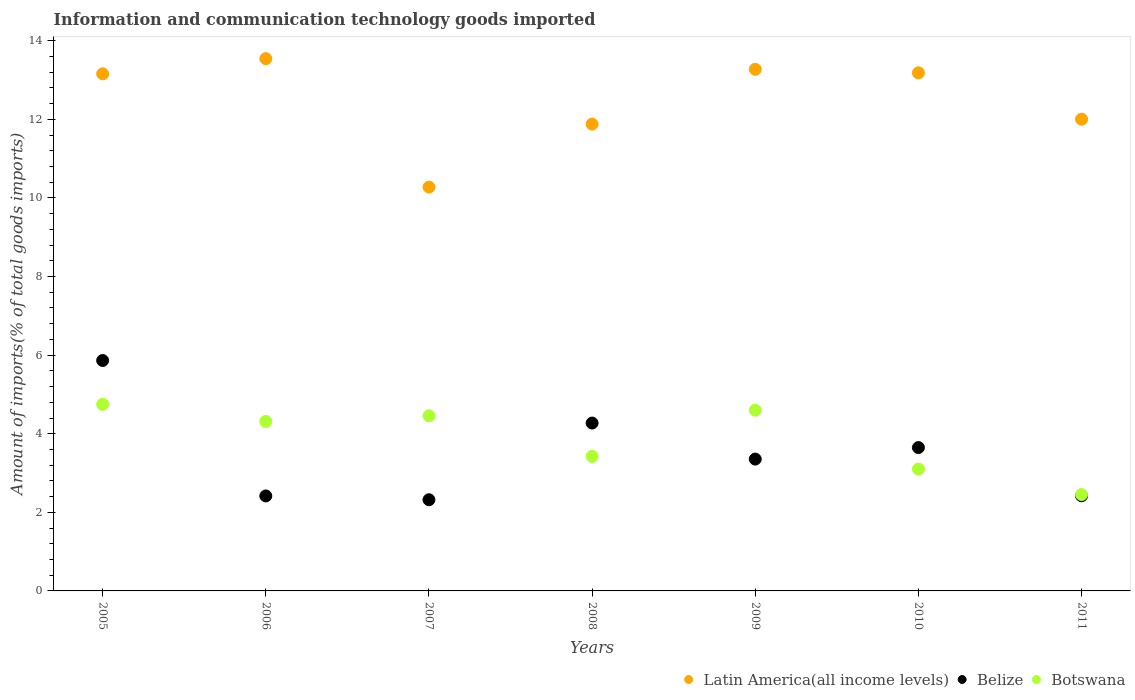How many different coloured dotlines are there?
Your response must be concise. 3. What is the amount of goods imported in Belize in 2007?
Your response must be concise. 2.32. Across all years, what is the maximum amount of goods imported in Belize?
Provide a short and direct response. 5.86. Across all years, what is the minimum amount of goods imported in Belize?
Offer a very short reply. 2.32. What is the total amount of goods imported in Botswana in the graph?
Provide a short and direct response. 27.09. What is the difference between the amount of goods imported in Latin America(all income levels) in 2007 and that in 2008?
Make the answer very short. -1.6. What is the difference between the amount of goods imported in Latin America(all income levels) in 2006 and the amount of goods imported in Botswana in 2005?
Make the answer very short. 8.8. What is the average amount of goods imported in Latin America(all income levels) per year?
Your answer should be compact. 12.47. In the year 2010, what is the difference between the amount of goods imported in Botswana and amount of goods imported in Latin America(all income levels)?
Provide a short and direct response. -10.08. What is the ratio of the amount of goods imported in Belize in 2006 to that in 2008?
Keep it short and to the point. 0.57. Is the amount of goods imported in Belize in 2009 less than that in 2010?
Ensure brevity in your answer.  Yes. Is the difference between the amount of goods imported in Botswana in 2006 and 2007 greater than the difference between the amount of goods imported in Latin America(all income levels) in 2006 and 2007?
Your response must be concise. No. What is the difference between the highest and the second highest amount of goods imported in Botswana?
Offer a terse response. 0.15. What is the difference between the highest and the lowest amount of goods imported in Latin America(all income levels)?
Your answer should be compact. 3.27. In how many years, is the amount of goods imported in Latin America(all income levels) greater than the average amount of goods imported in Latin America(all income levels) taken over all years?
Provide a short and direct response. 4. Is the sum of the amount of goods imported in Latin America(all income levels) in 2006 and 2008 greater than the maximum amount of goods imported in Belize across all years?
Give a very brief answer. Yes. Is it the case that in every year, the sum of the amount of goods imported in Belize and amount of goods imported in Botswana  is greater than the amount of goods imported in Latin America(all income levels)?
Your answer should be very brief. No. Does the amount of goods imported in Belize monotonically increase over the years?
Your answer should be compact. No. Is the amount of goods imported in Botswana strictly less than the amount of goods imported in Latin America(all income levels) over the years?
Your answer should be compact. Yes. How many dotlines are there?
Provide a short and direct response. 3. Are the values on the major ticks of Y-axis written in scientific E-notation?
Make the answer very short. No. Does the graph contain any zero values?
Offer a very short reply. No. Does the graph contain grids?
Provide a short and direct response. No. What is the title of the graph?
Make the answer very short. Information and communication technology goods imported. Does "Finland" appear as one of the legend labels in the graph?
Your answer should be very brief. No. What is the label or title of the X-axis?
Provide a succinct answer. Years. What is the label or title of the Y-axis?
Your answer should be very brief. Amount of imports(% of total goods imports). What is the Amount of imports(% of total goods imports) of Latin America(all income levels) in 2005?
Ensure brevity in your answer.  13.16. What is the Amount of imports(% of total goods imports) of Belize in 2005?
Ensure brevity in your answer.  5.86. What is the Amount of imports(% of total goods imports) of Botswana in 2005?
Your response must be concise. 4.75. What is the Amount of imports(% of total goods imports) in Latin America(all income levels) in 2006?
Offer a very short reply. 13.54. What is the Amount of imports(% of total goods imports) in Belize in 2006?
Make the answer very short. 2.42. What is the Amount of imports(% of total goods imports) in Botswana in 2006?
Your answer should be very brief. 4.31. What is the Amount of imports(% of total goods imports) of Latin America(all income levels) in 2007?
Your response must be concise. 10.28. What is the Amount of imports(% of total goods imports) in Belize in 2007?
Your answer should be compact. 2.32. What is the Amount of imports(% of total goods imports) of Botswana in 2007?
Provide a succinct answer. 4.46. What is the Amount of imports(% of total goods imports) of Latin America(all income levels) in 2008?
Your answer should be very brief. 11.88. What is the Amount of imports(% of total goods imports) of Belize in 2008?
Offer a terse response. 4.27. What is the Amount of imports(% of total goods imports) in Botswana in 2008?
Your answer should be very brief. 3.42. What is the Amount of imports(% of total goods imports) in Latin America(all income levels) in 2009?
Ensure brevity in your answer.  13.27. What is the Amount of imports(% of total goods imports) of Belize in 2009?
Make the answer very short. 3.35. What is the Amount of imports(% of total goods imports) of Botswana in 2009?
Offer a very short reply. 4.6. What is the Amount of imports(% of total goods imports) in Latin America(all income levels) in 2010?
Give a very brief answer. 13.18. What is the Amount of imports(% of total goods imports) in Belize in 2010?
Provide a short and direct response. 3.65. What is the Amount of imports(% of total goods imports) of Botswana in 2010?
Give a very brief answer. 3.1. What is the Amount of imports(% of total goods imports) of Latin America(all income levels) in 2011?
Offer a very short reply. 12.01. What is the Amount of imports(% of total goods imports) of Belize in 2011?
Keep it short and to the point. 2.42. What is the Amount of imports(% of total goods imports) in Botswana in 2011?
Your response must be concise. 2.45. Across all years, what is the maximum Amount of imports(% of total goods imports) of Latin America(all income levels)?
Your answer should be very brief. 13.54. Across all years, what is the maximum Amount of imports(% of total goods imports) in Belize?
Provide a succinct answer. 5.86. Across all years, what is the maximum Amount of imports(% of total goods imports) of Botswana?
Provide a short and direct response. 4.75. Across all years, what is the minimum Amount of imports(% of total goods imports) in Latin America(all income levels)?
Provide a succinct answer. 10.28. Across all years, what is the minimum Amount of imports(% of total goods imports) in Belize?
Your answer should be compact. 2.32. Across all years, what is the minimum Amount of imports(% of total goods imports) in Botswana?
Your answer should be compact. 2.45. What is the total Amount of imports(% of total goods imports) of Latin America(all income levels) in the graph?
Offer a terse response. 87.32. What is the total Amount of imports(% of total goods imports) of Belize in the graph?
Ensure brevity in your answer.  24.3. What is the total Amount of imports(% of total goods imports) in Botswana in the graph?
Provide a succinct answer. 27.09. What is the difference between the Amount of imports(% of total goods imports) of Latin America(all income levels) in 2005 and that in 2006?
Provide a short and direct response. -0.39. What is the difference between the Amount of imports(% of total goods imports) of Belize in 2005 and that in 2006?
Offer a very short reply. 3.45. What is the difference between the Amount of imports(% of total goods imports) of Botswana in 2005 and that in 2006?
Give a very brief answer. 0.43. What is the difference between the Amount of imports(% of total goods imports) in Latin America(all income levels) in 2005 and that in 2007?
Provide a succinct answer. 2.88. What is the difference between the Amount of imports(% of total goods imports) in Belize in 2005 and that in 2007?
Offer a very short reply. 3.54. What is the difference between the Amount of imports(% of total goods imports) in Botswana in 2005 and that in 2007?
Give a very brief answer. 0.29. What is the difference between the Amount of imports(% of total goods imports) in Latin America(all income levels) in 2005 and that in 2008?
Offer a very short reply. 1.28. What is the difference between the Amount of imports(% of total goods imports) in Belize in 2005 and that in 2008?
Ensure brevity in your answer.  1.59. What is the difference between the Amount of imports(% of total goods imports) of Botswana in 2005 and that in 2008?
Ensure brevity in your answer.  1.33. What is the difference between the Amount of imports(% of total goods imports) of Latin America(all income levels) in 2005 and that in 2009?
Provide a short and direct response. -0.12. What is the difference between the Amount of imports(% of total goods imports) of Belize in 2005 and that in 2009?
Offer a very short reply. 2.51. What is the difference between the Amount of imports(% of total goods imports) in Botswana in 2005 and that in 2009?
Offer a very short reply. 0.15. What is the difference between the Amount of imports(% of total goods imports) in Latin America(all income levels) in 2005 and that in 2010?
Your answer should be compact. -0.03. What is the difference between the Amount of imports(% of total goods imports) in Belize in 2005 and that in 2010?
Provide a succinct answer. 2.22. What is the difference between the Amount of imports(% of total goods imports) of Botswana in 2005 and that in 2010?
Your response must be concise. 1.65. What is the difference between the Amount of imports(% of total goods imports) of Latin America(all income levels) in 2005 and that in 2011?
Offer a terse response. 1.15. What is the difference between the Amount of imports(% of total goods imports) in Belize in 2005 and that in 2011?
Keep it short and to the point. 3.44. What is the difference between the Amount of imports(% of total goods imports) of Botswana in 2005 and that in 2011?
Make the answer very short. 2.3. What is the difference between the Amount of imports(% of total goods imports) of Latin America(all income levels) in 2006 and that in 2007?
Provide a short and direct response. 3.27. What is the difference between the Amount of imports(% of total goods imports) in Belize in 2006 and that in 2007?
Offer a very short reply. 0.1. What is the difference between the Amount of imports(% of total goods imports) in Botswana in 2006 and that in 2007?
Make the answer very short. -0.14. What is the difference between the Amount of imports(% of total goods imports) of Latin America(all income levels) in 2006 and that in 2008?
Your answer should be very brief. 1.67. What is the difference between the Amount of imports(% of total goods imports) of Belize in 2006 and that in 2008?
Offer a terse response. -1.85. What is the difference between the Amount of imports(% of total goods imports) in Botswana in 2006 and that in 2008?
Provide a succinct answer. 0.89. What is the difference between the Amount of imports(% of total goods imports) in Latin America(all income levels) in 2006 and that in 2009?
Offer a very short reply. 0.27. What is the difference between the Amount of imports(% of total goods imports) in Belize in 2006 and that in 2009?
Your answer should be very brief. -0.94. What is the difference between the Amount of imports(% of total goods imports) in Botswana in 2006 and that in 2009?
Provide a short and direct response. -0.28. What is the difference between the Amount of imports(% of total goods imports) of Latin America(all income levels) in 2006 and that in 2010?
Your answer should be compact. 0.36. What is the difference between the Amount of imports(% of total goods imports) in Belize in 2006 and that in 2010?
Ensure brevity in your answer.  -1.23. What is the difference between the Amount of imports(% of total goods imports) of Botswana in 2006 and that in 2010?
Offer a very short reply. 1.21. What is the difference between the Amount of imports(% of total goods imports) in Latin America(all income levels) in 2006 and that in 2011?
Give a very brief answer. 1.54. What is the difference between the Amount of imports(% of total goods imports) in Belize in 2006 and that in 2011?
Make the answer very short. -0. What is the difference between the Amount of imports(% of total goods imports) in Botswana in 2006 and that in 2011?
Provide a short and direct response. 1.86. What is the difference between the Amount of imports(% of total goods imports) in Latin America(all income levels) in 2007 and that in 2008?
Your answer should be compact. -1.6. What is the difference between the Amount of imports(% of total goods imports) of Belize in 2007 and that in 2008?
Your answer should be very brief. -1.95. What is the difference between the Amount of imports(% of total goods imports) of Botswana in 2007 and that in 2008?
Your answer should be compact. 1.03. What is the difference between the Amount of imports(% of total goods imports) of Latin America(all income levels) in 2007 and that in 2009?
Ensure brevity in your answer.  -3. What is the difference between the Amount of imports(% of total goods imports) of Belize in 2007 and that in 2009?
Keep it short and to the point. -1.03. What is the difference between the Amount of imports(% of total goods imports) of Botswana in 2007 and that in 2009?
Offer a very short reply. -0.14. What is the difference between the Amount of imports(% of total goods imports) in Latin America(all income levels) in 2007 and that in 2010?
Offer a very short reply. -2.91. What is the difference between the Amount of imports(% of total goods imports) of Belize in 2007 and that in 2010?
Offer a very short reply. -1.33. What is the difference between the Amount of imports(% of total goods imports) of Botswana in 2007 and that in 2010?
Give a very brief answer. 1.36. What is the difference between the Amount of imports(% of total goods imports) of Latin America(all income levels) in 2007 and that in 2011?
Keep it short and to the point. -1.73. What is the difference between the Amount of imports(% of total goods imports) in Belize in 2007 and that in 2011?
Provide a succinct answer. -0.1. What is the difference between the Amount of imports(% of total goods imports) in Botswana in 2007 and that in 2011?
Your answer should be very brief. 2. What is the difference between the Amount of imports(% of total goods imports) of Latin America(all income levels) in 2008 and that in 2009?
Your answer should be compact. -1.4. What is the difference between the Amount of imports(% of total goods imports) in Belize in 2008 and that in 2009?
Provide a short and direct response. 0.92. What is the difference between the Amount of imports(% of total goods imports) in Botswana in 2008 and that in 2009?
Offer a very short reply. -1.18. What is the difference between the Amount of imports(% of total goods imports) of Latin America(all income levels) in 2008 and that in 2010?
Provide a short and direct response. -1.3. What is the difference between the Amount of imports(% of total goods imports) in Belize in 2008 and that in 2010?
Provide a succinct answer. 0.62. What is the difference between the Amount of imports(% of total goods imports) of Botswana in 2008 and that in 2010?
Offer a very short reply. 0.32. What is the difference between the Amount of imports(% of total goods imports) of Latin America(all income levels) in 2008 and that in 2011?
Keep it short and to the point. -0.13. What is the difference between the Amount of imports(% of total goods imports) of Belize in 2008 and that in 2011?
Provide a short and direct response. 1.85. What is the difference between the Amount of imports(% of total goods imports) of Botswana in 2008 and that in 2011?
Provide a succinct answer. 0.97. What is the difference between the Amount of imports(% of total goods imports) of Latin America(all income levels) in 2009 and that in 2010?
Your answer should be compact. 0.09. What is the difference between the Amount of imports(% of total goods imports) of Belize in 2009 and that in 2010?
Your answer should be compact. -0.29. What is the difference between the Amount of imports(% of total goods imports) of Botswana in 2009 and that in 2010?
Provide a succinct answer. 1.5. What is the difference between the Amount of imports(% of total goods imports) in Latin America(all income levels) in 2009 and that in 2011?
Your answer should be very brief. 1.27. What is the difference between the Amount of imports(% of total goods imports) in Belize in 2009 and that in 2011?
Ensure brevity in your answer.  0.93. What is the difference between the Amount of imports(% of total goods imports) in Botswana in 2009 and that in 2011?
Ensure brevity in your answer.  2.15. What is the difference between the Amount of imports(% of total goods imports) in Latin America(all income levels) in 2010 and that in 2011?
Provide a short and direct response. 1.18. What is the difference between the Amount of imports(% of total goods imports) of Belize in 2010 and that in 2011?
Offer a terse response. 1.23. What is the difference between the Amount of imports(% of total goods imports) of Botswana in 2010 and that in 2011?
Ensure brevity in your answer.  0.65. What is the difference between the Amount of imports(% of total goods imports) of Latin America(all income levels) in 2005 and the Amount of imports(% of total goods imports) of Belize in 2006?
Ensure brevity in your answer.  10.74. What is the difference between the Amount of imports(% of total goods imports) in Latin America(all income levels) in 2005 and the Amount of imports(% of total goods imports) in Botswana in 2006?
Offer a very short reply. 8.84. What is the difference between the Amount of imports(% of total goods imports) in Belize in 2005 and the Amount of imports(% of total goods imports) in Botswana in 2006?
Your answer should be very brief. 1.55. What is the difference between the Amount of imports(% of total goods imports) in Latin America(all income levels) in 2005 and the Amount of imports(% of total goods imports) in Belize in 2007?
Offer a very short reply. 10.84. What is the difference between the Amount of imports(% of total goods imports) of Latin America(all income levels) in 2005 and the Amount of imports(% of total goods imports) of Botswana in 2007?
Give a very brief answer. 8.7. What is the difference between the Amount of imports(% of total goods imports) in Belize in 2005 and the Amount of imports(% of total goods imports) in Botswana in 2007?
Your response must be concise. 1.41. What is the difference between the Amount of imports(% of total goods imports) in Latin America(all income levels) in 2005 and the Amount of imports(% of total goods imports) in Belize in 2008?
Your answer should be compact. 8.89. What is the difference between the Amount of imports(% of total goods imports) in Latin America(all income levels) in 2005 and the Amount of imports(% of total goods imports) in Botswana in 2008?
Offer a terse response. 9.74. What is the difference between the Amount of imports(% of total goods imports) in Belize in 2005 and the Amount of imports(% of total goods imports) in Botswana in 2008?
Your answer should be very brief. 2.44. What is the difference between the Amount of imports(% of total goods imports) of Latin America(all income levels) in 2005 and the Amount of imports(% of total goods imports) of Belize in 2009?
Offer a terse response. 9.8. What is the difference between the Amount of imports(% of total goods imports) of Latin America(all income levels) in 2005 and the Amount of imports(% of total goods imports) of Botswana in 2009?
Ensure brevity in your answer.  8.56. What is the difference between the Amount of imports(% of total goods imports) of Belize in 2005 and the Amount of imports(% of total goods imports) of Botswana in 2009?
Keep it short and to the point. 1.26. What is the difference between the Amount of imports(% of total goods imports) of Latin America(all income levels) in 2005 and the Amount of imports(% of total goods imports) of Belize in 2010?
Your response must be concise. 9.51. What is the difference between the Amount of imports(% of total goods imports) of Latin America(all income levels) in 2005 and the Amount of imports(% of total goods imports) of Botswana in 2010?
Ensure brevity in your answer.  10.06. What is the difference between the Amount of imports(% of total goods imports) in Belize in 2005 and the Amount of imports(% of total goods imports) in Botswana in 2010?
Your answer should be very brief. 2.76. What is the difference between the Amount of imports(% of total goods imports) in Latin America(all income levels) in 2005 and the Amount of imports(% of total goods imports) in Belize in 2011?
Keep it short and to the point. 10.74. What is the difference between the Amount of imports(% of total goods imports) in Latin America(all income levels) in 2005 and the Amount of imports(% of total goods imports) in Botswana in 2011?
Ensure brevity in your answer.  10.71. What is the difference between the Amount of imports(% of total goods imports) of Belize in 2005 and the Amount of imports(% of total goods imports) of Botswana in 2011?
Provide a short and direct response. 3.41. What is the difference between the Amount of imports(% of total goods imports) of Latin America(all income levels) in 2006 and the Amount of imports(% of total goods imports) of Belize in 2007?
Offer a very short reply. 11.22. What is the difference between the Amount of imports(% of total goods imports) in Latin America(all income levels) in 2006 and the Amount of imports(% of total goods imports) in Botswana in 2007?
Offer a very short reply. 9.09. What is the difference between the Amount of imports(% of total goods imports) of Belize in 2006 and the Amount of imports(% of total goods imports) of Botswana in 2007?
Ensure brevity in your answer.  -2.04. What is the difference between the Amount of imports(% of total goods imports) of Latin America(all income levels) in 2006 and the Amount of imports(% of total goods imports) of Belize in 2008?
Your answer should be very brief. 9.27. What is the difference between the Amount of imports(% of total goods imports) of Latin America(all income levels) in 2006 and the Amount of imports(% of total goods imports) of Botswana in 2008?
Offer a very short reply. 10.12. What is the difference between the Amount of imports(% of total goods imports) of Belize in 2006 and the Amount of imports(% of total goods imports) of Botswana in 2008?
Provide a short and direct response. -1.01. What is the difference between the Amount of imports(% of total goods imports) of Latin America(all income levels) in 2006 and the Amount of imports(% of total goods imports) of Belize in 2009?
Give a very brief answer. 10.19. What is the difference between the Amount of imports(% of total goods imports) in Latin America(all income levels) in 2006 and the Amount of imports(% of total goods imports) in Botswana in 2009?
Make the answer very short. 8.95. What is the difference between the Amount of imports(% of total goods imports) of Belize in 2006 and the Amount of imports(% of total goods imports) of Botswana in 2009?
Provide a succinct answer. -2.18. What is the difference between the Amount of imports(% of total goods imports) of Latin America(all income levels) in 2006 and the Amount of imports(% of total goods imports) of Belize in 2010?
Ensure brevity in your answer.  9.9. What is the difference between the Amount of imports(% of total goods imports) in Latin America(all income levels) in 2006 and the Amount of imports(% of total goods imports) in Botswana in 2010?
Keep it short and to the point. 10.44. What is the difference between the Amount of imports(% of total goods imports) of Belize in 2006 and the Amount of imports(% of total goods imports) of Botswana in 2010?
Your response must be concise. -0.68. What is the difference between the Amount of imports(% of total goods imports) in Latin America(all income levels) in 2006 and the Amount of imports(% of total goods imports) in Belize in 2011?
Your answer should be compact. 11.12. What is the difference between the Amount of imports(% of total goods imports) of Latin America(all income levels) in 2006 and the Amount of imports(% of total goods imports) of Botswana in 2011?
Make the answer very short. 11.09. What is the difference between the Amount of imports(% of total goods imports) in Belize in 2006 and the Amount of imports(% of total goods imports) in Botswana in 2011?
Offer a terse response. -0.04. What is the difference between the Amount of imports(% of total goods imports) of Latin America(all income levels) in 2007 and the Amount of imports(% of total goods imports) of Belize in 2008?
Your answer should be very brief. 6. What is the difference between the Amount of imports(% of total goods imports) in Latin America(all income levels) in 2007 and the Amount of imports(% of total goods imports) in Botswana in 2008?
Give a very brief answer. 6.85. What is the difference between the Amount of imports(% of total goods imports) of Belize in 2007 and the Amount of imports(% of total goods imports) of Botswana in 2008?
Your response must be concise. -1.1. What is the difference between the Amount of imports(% of total goods imports) in Latin America(all income levels) in 2007 and the Amount of imports(% of total goods imports) in Belize in 2009?
Make the answer very short. 6.92. What is the difference between the Amount of imports(% of total goods imports) of Latin America(all income levels) in 2007 and the Amount of imports(% of total goods imports) of Botswana in 2009?
Offer a terse response. 5.68. What is the difference between the Amount of imports(% of total goods imports) in Belize in 2007 and the Amount of imports(% of total goods imports) in Botswana in 2009?
Ensure brevity in your answer.  -2.28. What is the difference between the Amount of imports(% of total goods imports) in Latin America(all income levels) in 2007 and the Amount of imports(% of total goods imports) in Belize in 2010?
Your response must be concise. 6.63. What is the difference between the Amount of imports(% of total goods imports) of Latin America(all income levels) in 2007 and the Amount of imports(% of total goods imports) of Botswana in 2010?
Your answer should be compact. 7.18. What is the difference between the Amount of imports(% of total goods imports) in Belize in 2007 and the Amount of imports(% of total goods imports) in Botswana in 2010?
Your answer should be very brief. -0.78. What is the difference between the Amount of imports(% of total goods imports) of Latin America(all income levels) in 2007 and the Amount of imports(% of total goods imports) of Belize in 2011?
Your answer should be compact. 7.86. What is the difference between the Amount of imports(% of total goods imports) in Latin America(all income levels) in 2007 and the Amount of imports(% of total goods imports) in Botswana in 2011?
Ensure brevity in your answer.  7.82. What is the difference between the Amount of imports(% of total goods imports) of Belize in 2007 and the Amount of imports(% of total goods imports) of Botswana in 2011?
Ensure brevity in your answer.  -0.13. What is the difference between the Amount of imports(% of total goods imports) in Latin America(all income levels) in 2008 and the Amount of imports(% of total goods imports) in Belize in 2009?
Keep it short and to the point. 8.52. What is the difference between the Amount of imports(% of total goods imports) of Latin America(all income levels) in 2008 and the Amount of imports(% of total goods imports) of Botswana in 2009?
Provide a short and direct response. 7.28. What is the difference between the Amount of imports(% of total goods imports) in Belize in 2008 and the Amount of imports(% of total goods imports) in Botswana in 2009?
Give a very brief answer. -0.33. What is the difference between the Amount of imports(% of total goods imports) in Latin America(all income levels) in 2008 and the Amount of imports(% of total goods imports) in Belize in 2010?
Your answer should be very brief. 8.23. What is the difference between the Amount of imports(% of total goods imports) of Latin America(all income levels) in 2008 and the Amount of imports(% of total goods imports) of Botswana in 2010?
Your response must be concise. 8.78. What is the difference between the Amount of imports(% of total goods imports) in Belize in 2008 and the Amount of imports(% of total goods imports) in Botswana in 2010?
Your response must be concise. 1.17. What is the difference between the Amount of imports(% of total goods imports) in Latin America(all income levels) in 2008 and the Amount of imports(% of total goods imports) in Belize in 2011?
Ensure brevity in your answer.  9.46. What is the difference between the Amount of imports(% of total goods imports) in Latin America(all income levels) in 2008 and the Amount of imports(% of total goods imports) in Botswana in 2011?
Ensure brevity in your answer.  9.43. What is the difference between the Amount of imports(% of total goods imports) of Belize in 2008 and the Amount of imports(% of total goods imports) of Botswana in 2011?
Your answer should be compact. 1.82. What is the difference between the Amount of imports(% of total goods imports) in Latin America(all income levels) in 2009 and the Amount of imports(% of total goods imports) in Belize in 2010?
Give a very brief answer. 9.63. What is the difference between the Amount of imports(% of total goods imports) of Latin America(all income levels) in 2009 and the Amount of imports(% of total goods imports) of Botswana in 2010?
Your answer should be very brief. 10.17. What is the difference between the Amount of imports(% of total goods imports) of Belize in 2009 and the Amount of imports(% of total goods imports) of Botswana in 2010?
Keep it short and to the point. 0.25. What is the difference between the Amount of imports(% of total goods imports) in Latin America(all income levels) in 2009 and the Amount of imports(% of total goods imports) in Belize in 2011?
Provide a short and direct response. 10.85. What is the difference between the Amount of imports(% of total goods imports) in Latin America(all income levels) in 2009 and the Amount of imports(% of total goods imports) in Botswana in 2011?
Make the answer very short. 10.82. What is the difference between the Amount of imports(% of total goods imports) in Belize in 2009 and the Amount of imports(% of total goods imports) in Botswana in 2011?
Offer a very short reply. 0.9. What is the difference between the Amount of imports(% of total goods imports) of Latin America(all income levels) in 2010 and the Amount of imports(% of total goods imports) of Belize in 2011?
Provide a short and direct response. 10.76. What is the difference between the Amount of imports(% of total goods imports) in Latin America(all income levels) in 2010 and the Amount of imports(% of total goods imports) in Botswana in 2011?
Make the answer very short. 10.73. What is the difference between the Amount of imports(% of total goods imports) in Belize in 2010 and the Amount of imports(% of total goods imports) in Botswana in 2011?
Your response must be concise. 1.2. What is the average Amount of imports(% of total goods imports) in Latin America(all income levels) per year?
Ensure brevity in your answer.  12.47. What is the average Amount of imports(% of total goods imports) of Belize per year?
Keep it short and to the point. 3.47. What is the average Amount of imports(% of total goods imports) in Botswana per year?
Make the answer very short. 3.87. In the year 2005, what is the difference between the Amount of imports(% of total goods imports) of Latin America(all income levels) and Amount of imports(% of total goods imports) of Belize?
Provide a succinct answer. 7.29. In the year 2005, what is the difference between the Amount of imports(% of total goods imports) of Latin America(all income levels) and Amount of imports(% of total goods imports) of Botswana?
Ensure brevity in your answer.  8.41. In the year 2005, what is the difference between the Amount of imports(% of total goods imports) of Belize and Amount of imports(% of total goods imports) of Botswana?
Offer a terse response. 1.11. In the year 2006, what is the difference between the Amount of imports(% of total goods imports) in Latin America(all income levels) and Amount of imports(% of total goods imports) in Belize?
Give a very brief answer. 11.13. In the year 2006, what is the difference between the Amount of imports(% of total goods imports) of Latin America(all income levels) and Amount of imports(% of total goods imports) of Botswana?
Give a very brief answer. 9.23. In the year 2006, what is the difference between the Amount of imports(% of total goods imports) of Belize and Amount of imports(% of total goods imports) of Botswana?
Make the answer very short. -1.9. In the year 2007, what is the difference between the Amount of imports(% of total goods imports) of Latin America(all income levels) and Amount of imports(% of total goods imports) of Belize?
Your response must be concise. 7.96. In the year 2007, what is the difference between the Amount of imports(% of total goods imports) of Latin America(all income levels) and Amount of imports(% of total goods imports) of Botswana?
Offer a very short reply. 5.82. In the year 2007, what is the difference between the Amount of imports(% of total goods imports) in Belize and Amount of imports(% of total goods imports) in Botswana?
Your answer should be very brief. -2.14. In the year 2008, what is the difference between the Amount of imports(% of total goods imports) in Latin America(all income levels) and Amount of imports(% of total goods imports) in Belize?
Your answer should be very brief. 7.61. In the year 2008, what is the difference between the Amount of imports(% of total goods imports) of Latin America(all income levels) and Amount of imports(% of total goods imports) of Botswana?
Make the answer very short. 8.46. In the year 2008, what is the difference between the Amount of imports(% of total goods imports) of Belize and Amount of imports(% of total goods imports) of Botswana?
Your answer should be very brief. 0.85. In the year 2009, what is the difference between the Amount of imports(% of total goods imports) of Latin America(all income levels) and Amount of imports(% of total goods imports) of Belize?
Provide a short and direct response. 9.92. In the year 2009, what is the difference between the Amount of imports(% of total goods imports) of Latin America(all income levels) and Amount of imports(% of total goods imports) of Botswana?
Your response must be concise. 8.68. In the year 2009, what is the difference between the Amount of imports(% of total goods imports) in Belize and Amount of imports(% of total goods imports) in Botswana?
Provide a succinct answer. -1.24. In the year 2010, what is the difference between the Amount of imports(% of total goods imports) in Latin America(all income levels) and Amount of imports(% of total goods imports) in Belize?
Provide a succinct answer. 9.54. In the year 2010, what is the difference between the Amount of imports(% of total goods imports) in Latin America(all income levels) and Amount of imports(% of total goods imports) in Botswana?
Provide a succinct answer. 10.08. In the year 2010, what is the difference between the Amount of imports(% of total goods imports) of Belize and Amount of imports(% of total goods imports) of Botswana?
Your answer should be compact. 0.55. In the year 2011, what is the difference between the Amount of imports(% of total goods imports) in Latin America(all income levels) and Amount of imports(% of total goods imports) in Belize?
Your response must be concise. 9.58. In the year 2011, what is the difference between the Amount of imports(% of total goods imports) of Latin America(all income levels) and Amount of imports(% of total goods imports) of Botswana?
Offer a very short reply. 9.55. In the year 2011, what is the difference between the Amount of imports(% of total goods imports) in Belize and Amount of imports(% of total goods imports) in Botswana?
Provide a short and direct response. -0.03. What is the ratio of the Amount of imports(% of total goods imports) in Latin America(all income levels) in 2005 to that in 2006?
Provide a succinct answer. 0.97. What is the ratio of the Amount of imports(% of total goods imports) of Belize in 2005 to that in 2006?
Offer a very short reply. 2.43. What is the ratio of the Amount of imports(% of total goods imports) of Botswana in 2005 to that in 2006?
Ensure brevity in your answer.  1.1. What is the ratio of the Amount of imports(% of total goods imports) in Latin America(all income levels) in 2005 to that in 2007?
Provide a short and direct response. 1.28. What is the ratio of the Amount of imports(% of total goods imports) of Belize in 2005 to that in 2007?
Ensure brevity in your answer.  2.53. What is the ratio of the Amount of imports(% of total goods imports) in Botswana in 2005 to that in 2007?
Ensure brevity in your answer.  1.07. What is the ratio of the Amount of imports(% of total goods imports) in Latin America(all income levels) in 2005 to that in 2008?
Give a very brief answer. 1.11. What is the ratio of the Amount of imports(% of total goods imports) in Belize in 2005 to that in 2008?
Provide a short and direct response. 1.37. What is the ratio of the Amount of imports(% of total goods imports) in Botswana in 2005 to that in 2008?
Make the answer very short. 1.39. What is the ratio of the Amount of imports(% of total goods imports) in Belize in 2005 to that in 2009?
Give a very brief answer. 1.75. What is the ratio of the Amount of imports(% of total goods imports) of Botswana in 2005 to that in 2009?
Offer a terse response. 1.03. What is the ratio of the Amount of imports(% of total goods imports) of Latin America(all income levels) in 2005 to that in 2010?
Make the answer very short. 1. What is the ratio of the Amount of imports(% of total goods imports) of Belize in 2005 to that in 2010?
Your answer should be very brief. 1.61. What is the ratio of the Amount of imports(% of total goods imports) in Botswana in 2005 to that in 2010?
Make the answer very short. 1.53. What is the ratio of the Amount of imports(% of total goods imports) of Latin America(all income levels) in 2005 to that in 2011?
Give a very brief answer. 1.1. What is the ratio of the Amount of imports(% of total goods imports) of Belize in 2005 to that in 2011?
Make the answer very short. 2.42. What is the ratio of the Amount of imports(% of total goods imports) in Botswana in 2005 to that in 2011?
Ensure brevity in your answer.  1.94. What is the ratio of the Amount of imports(% of total goods imports) of Latin America(all income levels) in 2006 to that in 2007?
Offer a very short reply. 1.32. What is the ratio of the Amount of imports(% of total goods imports) of Belize in 2006 to that in 2007?
Provide a succinct answer. 1.04. What is the ratio of the Amount of imports(% of total goods imports) of Botswana in 2006 to that in 2007?
Your answer should be compact. 0.97. What is the ratio of the Amount of imports(% of total goods imports) in Latin America(all income levels) in 2006 to that in 2008?
Offer a very short reply. 1.14. What is the ratio of the Amount of imports(% of total goods imports) of Belize in 2006 to that in 2008?
Give a very brief answer. 0.57. What is the ratio of the Amount of imports(% of total goods imports) of Botswana in 2006 to that in 2008?
Provide a succinct answer. 1.26. What is the ratio of the Amount of imports(% of total goods imports) in Latin America(all income levels) in 2006 to that in 2009?
Provide a succinct answer. 1.02. What is the ratio of the Amount of imports(% of total goods imports) in Belize in 2006 to that in 2009?
Make the answer very short. 0.72. What is the ratio of the Amount of imports(% of total goods imports) in Botswana in 2006 to that in 2009?
Your response must be concise. 0.94. What is the ratio of the Amount of imports(% of total goods imports) in Latin America(all income levels) in 2006 to that in 2010?
Provide a succinct answer. 1.03. What is the ratio of the Amount of imports(% of total goods imports) in Belize in 2006 to that in 2010?
Offer a terse response. 0.66. What is the ratio of the Amount of imports(% of total goods imports) in Botswana in 2006 to that in 2010?
Your answer should be very brief. 1.39. What is the ratio of the Amount of imports(% of total goods imports) in Latin America(all income levels) in 2006 to that in 2011?
Keep it short and to the point. 1.13. What is the ratio of the Amount of imports(% of total goods imports) in Botswana in 2006 to that in 2011?
Ensure brevity in your answer.  1.76. What is the ratio of the Amount of imports(% of total goods imports) in Latin America(all income levels) in 2007 to that in 2008?
Make the answer very short. 0.87. What is the ratio of the Amount of imports(% of total goods imports) of Belize in 2007 to that in 2008?
Provide a short and direct response. 0.54. What is the ratio of the Amount of imports(% of total goods imports) of Botswana in 2007 to that in 2008?
Make the answer very short. 1.3. What is the ratio of the Amount of imports(% of total goods imports) of Latin America(all income levels) in 2007 to that in 2009?
Provide a short and direct response. 0.77. What is the ratio of the Amount of imports(% of total goods imports) in Belize in 2007 to that in 2009?
Your answer should be very brief. 0.69. What is the ratio of the Amount of imports(% of total goods imports) of Botswana in 2007 to that in 2009?
Your answer should be compact. 0.97. What is the ratio of the Amount of imports(% of total goods imports) of Latin America(all income levels) in 2007 to that in 2010?
Give a very brief answer. 0.78. What is the ratio of the Amount of imports(% of total goods imports) of Belize in 2007 to that in 2010?
Your answer should be very brief. 0.64. What is the ratio of the Amount of imports(% of total goods imports) in Botswana in 2007 to that in 2010?
Provide a short and direct response. 1.44. What is the ratio of the Amount of imports(% of total goods imports) of Latin America(all income levels) in 2007 to that in 2011?
Your answer should be very brief. 0.86. What is the ratio of the Amount of imports(% of total goods imports) in Belize in 2007 to that in 2011?
Provide a short and direct response. 0.96. What is the ratio of the Amount of imports(% of total goods imports) of Botswana in 2007 to that in 2011?
Your response must be concise. 1.82. What is the ratio of the Amount of imports(% of total goods imports) of Latin America(all income levels) in 2008 to that in 2009?
Offer a very short reply. 0.89. What is the ratio of the Amount of imports(% of total goods imports) of Belize in 2008 to that in 2009?
Provide a succinct answer. 1.27. What is the ratio of the Amount of imports(% of total goods imports) of Botswana in 2008 to that in 2009?
Provide a succinct answer. 0.74. What is the ratio of the Amount of imports(% of total goods imports) in Latin America(all income levels) in 2008 to that in 2010?
Your answer should be compact. 0.9. What is the ratio of the Amount of imports(% of total goods imports) in Belize in 2008 to that in 2010?
Keep it short and to the point. 1.17. What is the ratio of the Amount of imports(% of total goods imports) in Botswana in 2008 to that in 2010?
Provide a succinct answer. 1.1. What is the ratio of the Amount of imports(% of total goods imports) in Belize in 2008 to that in 2011?
Ensure brevity in your answer.  1.76. What is the ratio of the Amount of imports(% of total goods imports) in Botswana in 2008 to that in 2011?
Offer a very short reply. 1.4. What is the ratio of the Amount of imports(% of total goods imports) in Latin America(all income levels) in 2009 to that in 2010?
Provide a short and direct response. 1.01. What is the ratio of the Amount of imports(% of total goods imports) in Belize in 2009 to that in 2010?
Make the answer very short. 0.92. What is the ratio of the Amount of imports(% of total goods imports) in Botswana in 2009 to that in 2010?
Offer a very short reply. 1.48. What is the ratio of the Amount of imports(% of total goods imports) in Latin America(all income levels) in 2009 to that in 2011?
Provide a short and direct response. 1.11. What is the ratio of the Amount of imports(% of total goods imports) in Belize in 2009 to that in 2011?
Offer a terse response. 1.39. What is the ratio of the Amount of imports(% of total goods imports) of Botswana in 2009 to that in 2011?
Keep it short and to the point. 1.88. What is the ratio of the Amount of imports(% of total goods imports) in Latin America(all income levels) in 2010 to that in 2011?
Offer a very short reply. 1.1. What is the ratio of the Amount of imports(% of total goods imports) in Belize in 2010 to that in 2011?
Offer a terse response. 1.51. What is the ratio of the Amount of imports(% of total goods imports) of Botswana in 2010 to that in 2011?
Provide a succinct answer. 1.26. What is the difference between the highest and the second highest Amount of imports(% of total goods imports) in Latin America(all income levels)?
Your answer should be compact. 0.27. What is the difference between the highest and the second highest Amount of imports(% of total goods imports) of Belize?
Keep it short and to the point. 1.59. What is the difference between the highest and the second highest Amount of imports(% of total goods imports) in Botswana?
Offer a terse response. 0.15. What is the difference between the highest and the lowest Amount of imports(% of total goods imports) in Latin America(all income levels)?
Ensure brevity in your answer.  3.27. What is the difference between the highest and the lowest Amount of imports(% of total goods imports) of Belize?
Keep it short and to the point. 3.54. What is the difference between the highest and the lowest Amount of imports(% of total goods imports) of Botswana?
Your response must be concise. 2.3. 